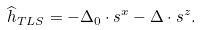<formula> <loc_0><loc_0><loc_500><loc_500>\widehat { h } _ { T L S } = - \Delta _ { 0 } \cdot s ^ { x } - \Delta \cdot s ^ { z } .</formula> 